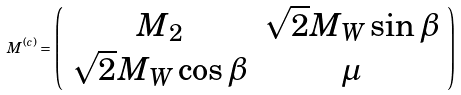Convert formula to latex. <formula><loc_0><loc_0><loc_500><loc_500>M ^ { ( c ) } = \left ( \begin{array} { c c } M _ { 2 } & \sqrt { 2 } M _ { W } \sin \beta \\ \sqrt { 2 } M _ { W } \cos \beta & \mu \end{array} \right )</formula> 